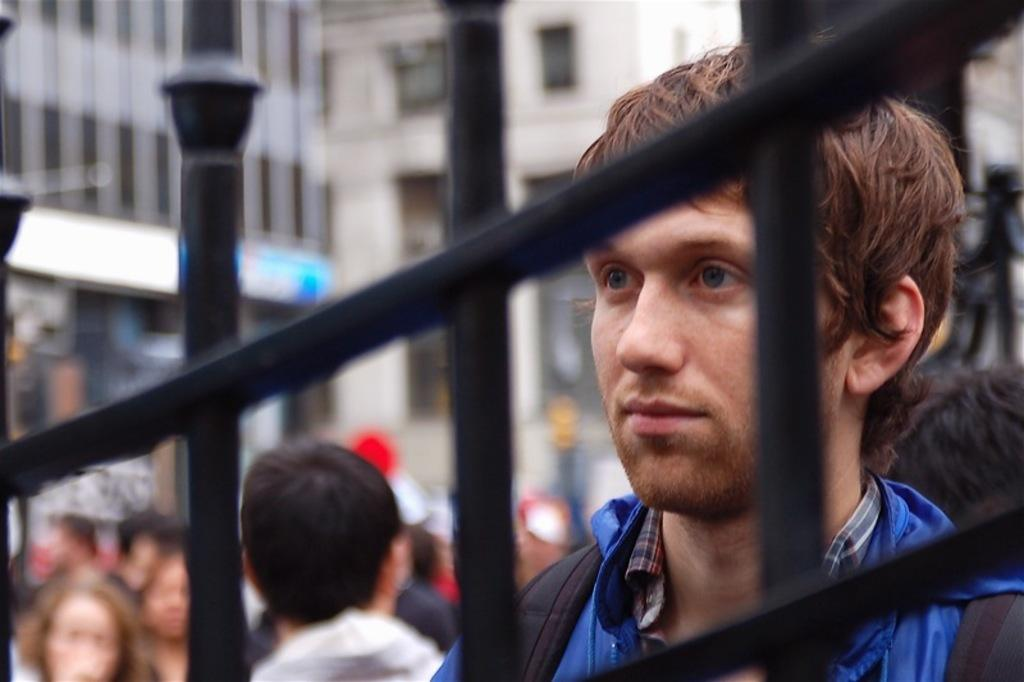What type of structures can be seen in the background of the image? There are buildings in the background of the image. How are the buildings depicted in the image? The buildings are blurred in the image. Who or what else is present in the image? There are people in the image. What specific objects can be seen in the image? There are black grills in the image. Can you describe the appearance of one of the individuals in the image? There is a man wearing a blue jacket in the image. What thought is the man wearing a blue jacket having in the image? There is no indication of the man's thoughts in the image, as we cannot see inside his mind. What do you believe the end result of the situation in the image will be? We cannot predict the future or the end result of the situation in the image, as it is a static representation. 